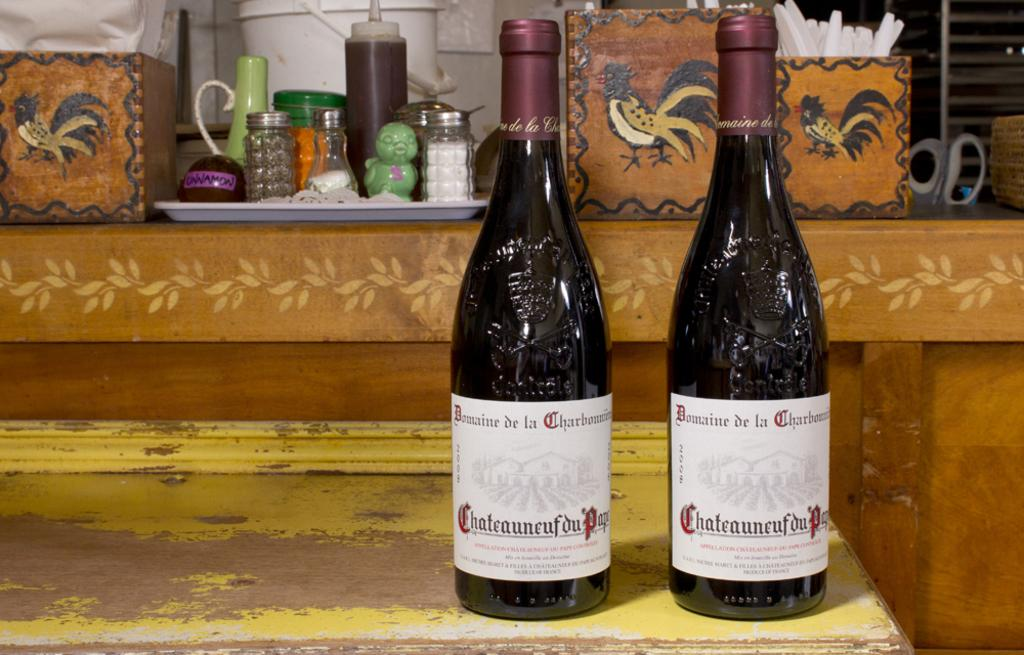<image>
Present a compact description of the photo's key features. Two bottles of Chateauneuf du Papi wine are sitting on a counter. 